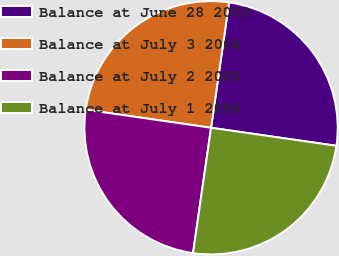<chart> <loc_0><loc_0><loc_500><loc_500><pie_chart><fcel>Balance at June 28 2003<fcel>Balance at July 3 2004<fcel>Balance at July 2 2005<fcel>Balance at July 1 2006<nl><fcel>25.0%<fcel>25.0%<fcel>25.0%<fcel>25.0%<nl></chart> 